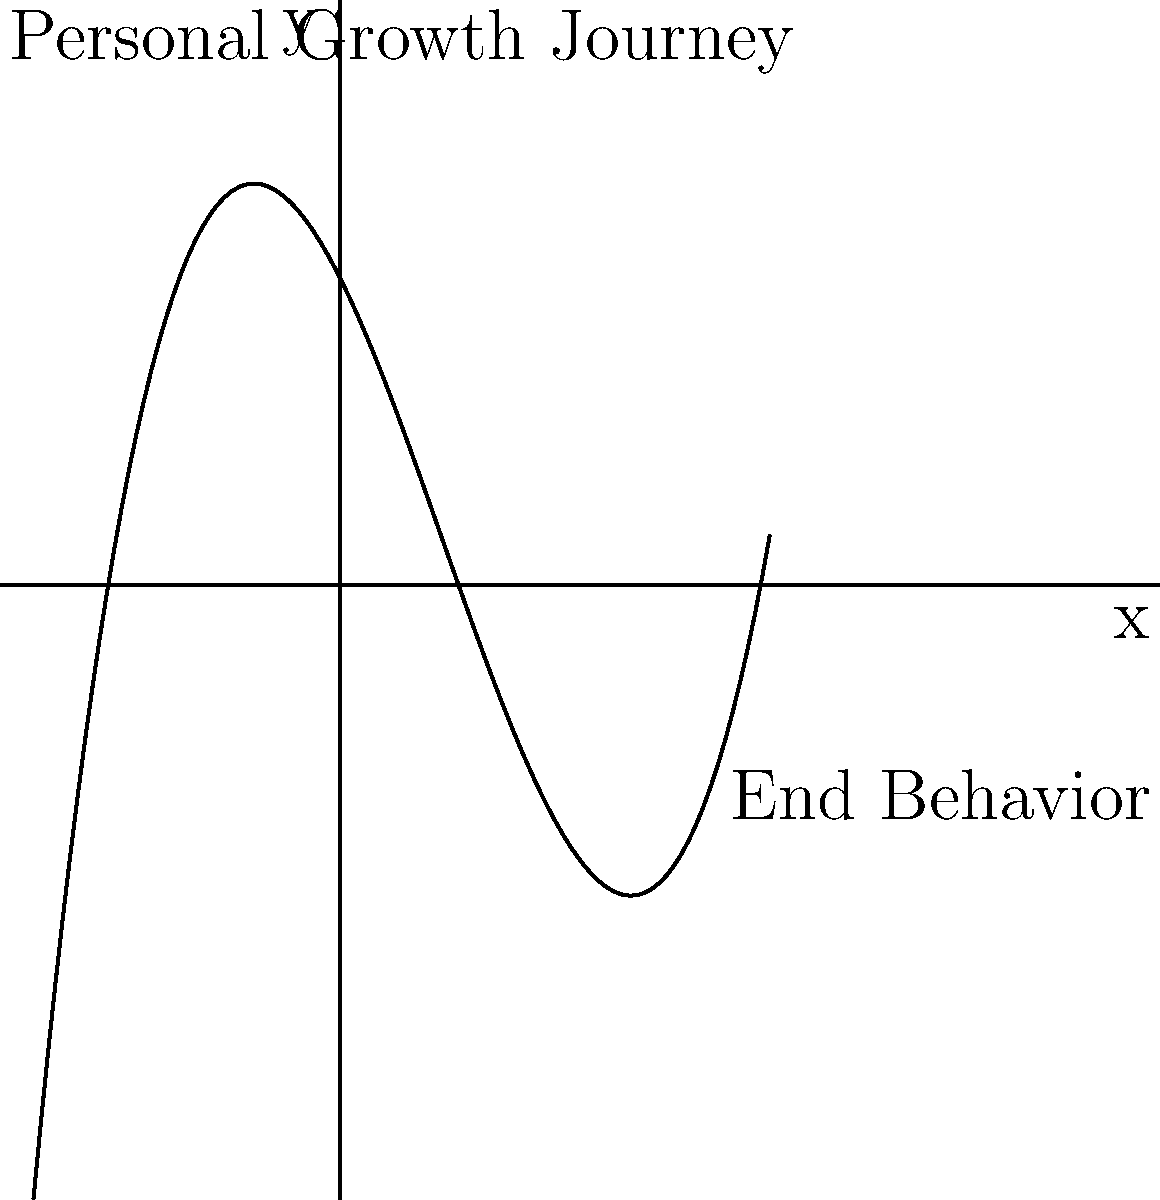In the context of personal growth journeys, consider the polynomial function $f(x) = 0.1x^3 - 0.5x^2 - 2x + 5$ shown in the graph. As $x$ approaches positive infinity, what does the end behavior of this function suggest about long-term personal development? To understand the end behavior of this polynomial function and its metaphorical relationship to personal growth, let's follow these steps:

1. Identify the degree and leading coefficient:
   - The polynomial is of degree 3 (cubic function).
   - The leading coefficient is 0.1 (positive).

2. Determine the end behavior:
   - For odd-degree polynomials with a positive leading coefficient, as $x$ approaches positive infinity, $f(x)$ approaches positive infinity.
   - Mathematically, we can write this as: $\lim_{x \to +\infty} f(x) = +\infty$

3. Interpret the end behavior:
   - The graph shows an overall upward trend as $x$ increases.
   - Despite local fluctuations (ups and downs), the long-term trajectory is positive.

4. Relate to personal growth:
   - The upward trend suggests that over time, personal growth leads to overall positive development.
   - Fluctuations in the graph represent challenges or setbacks in life.
   - The end behavior indicates that with persistent effort, personal growth continues indefinitely.

5. Conclusion:
   - The end behavior of this polynomial function, approaching positive infinity, metaphorically represents continuous, long-term personal growth and improvement.
Answer: Continuous, upward personal development 